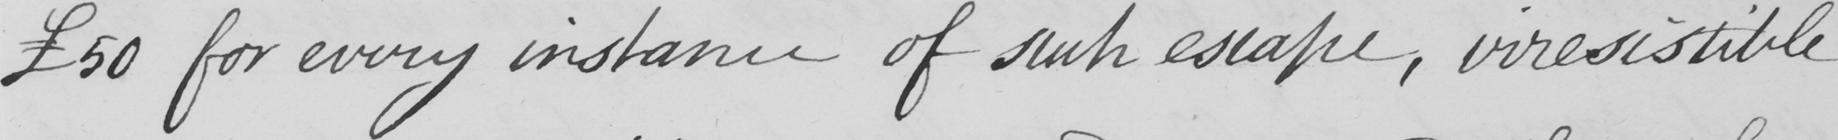Transcribe the text shown in this historical manuscript line. £50 for every instance of such escape , irresistible 